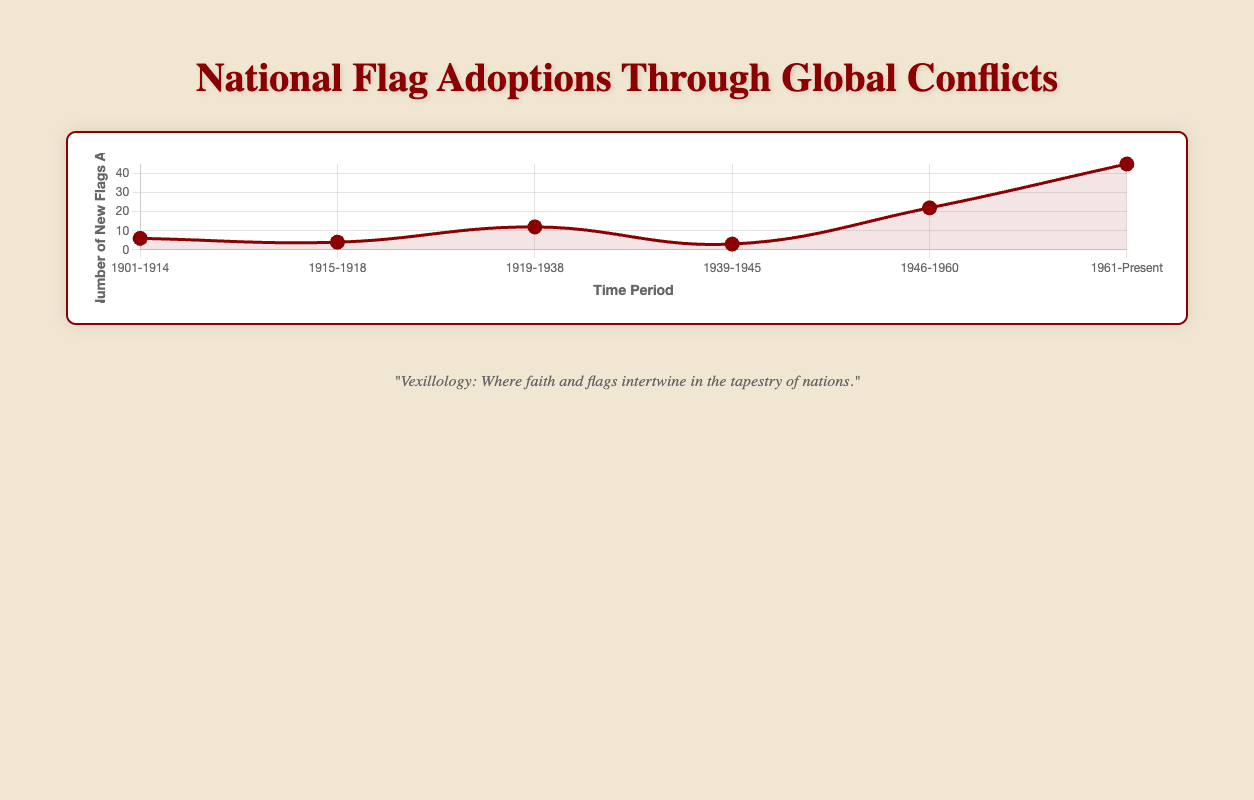How many new flags were adopted during World War I and World War II combined? During World War I, 4 new flags were adopted. During World War II, 3 new flags were adopted. Adding these together: 4 + 3 = 7
Answer: 7 Which period saw the highest number of new flags adopted? The plot shows the highest peak during the "Post Colonial Era" (1961-Present) with 45 new flags adopted.
Answer: Post Colonial Era (1961-Present) What is the difference in the number of new flags adopted between the Interwar Period and Post World War II period? During the Interwar Period, 12 new flags were adopted. In the Post World War II period, 22 new flags were adopted. The difference is 22 - 12 = 10
Answer: 10 Which periods had fewer than 10 new flags adopted? The periods with fewer than 10 new flags adopted are "Before World War I" (6 new flags), "During World War I" (4 new flags), and "During World War II" (3 new flags).
Answer: Before World War I, During World War I, During World War II How many new flags were adopted from 1946 to 1960 as compared to 1901 to 1914? From 1946 to 1960, 22 new flags were adopted. From 1901 to 1914, 6 new flags were adopted. The difference is 22 - 6 = 16
Answer: 16 What is the average number of new flags adopted per period for the given data? Add the number of new flags adopted across all periods and divide by the number of periods. (6+4+12+3+22+45) / 6 = 92 / 6 = 15.33
Answer: 15.33 During which period did the fewest number of new flags get adopted? The fewest number of new flags adopted was during "During World War II" with 3 new flags adopted.
Answer: During World War II Compare the number of new flags adopted in the "Interwar Period" and the "Post Colonial Era." The Interwar Period had 12 new flags adopted, and the Post Colonial Era had 45 new flags adopted. 45 is greater than 12.
Answer: Post Colonial Era > Interwar Period Which color is used to represent the data points in the plot? The data points in the plot are represented in red color.
Answer: Red What is the median number of new flags adopted across all listed periods? The sorted numbers of new flags are 3, 4, 6, 12, 22, 45. The median is the average of the 3rd and 4th values: (6 + 12) / 2 = 9
Answer: 9 